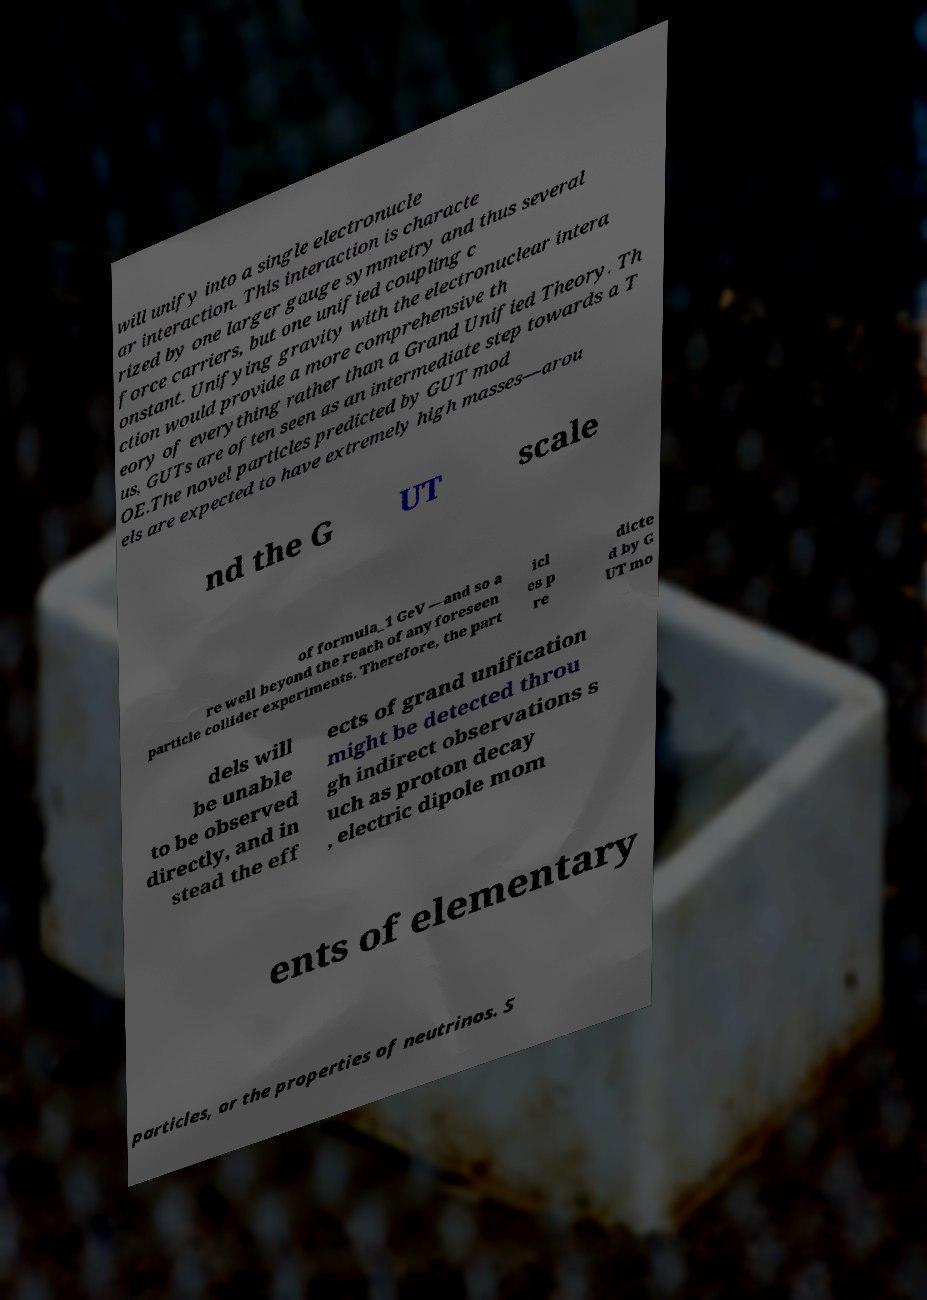There's text embedded in this image that I need extracted. Can you transcribe it verbatim? will unify into a single electronucle ar interaction. This interaction is characte rized by one larger gauge symmetry and thus several force carriers, but one unified coupling c onstant. Unifying gravity with the electronuclear intera ction would provide a more comprehensive th eory of everything rather than a Grand Unified Theory. Th us, GUTs are often seen as an intermediate step towards a T OE.The novel particles predicted by GUT mod els are expected to have extremely high masses—arou nd the G UT scale of formula_1 GeV —and so a re well beyond the reach of any foreseen particle collider experiments. Therefore, the part icl es p re dicte d by G UT mo dels will be unable to be observed directly, and in stead the eff ects of grand unification might be detected throu gh indirect observations s uch as proton decay , electric dipole mom ents of elementary particles, or the properties of neutrinos. S 